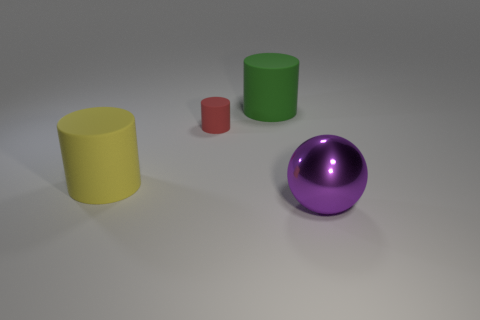Are there any other things that have the same material as the ball?
Give a very brief answer. No. There is a green rubber cylinder on the right side of the large rubber cylinder that is in front of the green thing; is there a green cylinder to the left of it?
Your answer should be compact. No. There is a rubber thing that is right of the small matte thing; is it the same color as the small object?
Offer a terse response. No. How many spheres are either cyan shiny objects or green objects?
Provide a succinct answer. 0. There is a big rubber thing in front of the big thing that is behind the big yellow thing; what is its shape?
Offer a very short reply. Cylinder. What is the size of the object that is in front of the big matte object that is left of the large rubber thing behind the large yellow rubber cylinder?
Make the answer very short. Large. Is the size of the red rubber cylinder the same as the purple metallic ball?
Provide a succinct answer. No. How many objects are either small red rubber objects or big purple cylinders?
Your answer should be very brief. 1. There is a thing in front of the rubber thing left of the small red cylinder; how big is it?
Provide a short and direct response. Large. What size is the ball?
Your answer should be compact. Large. 